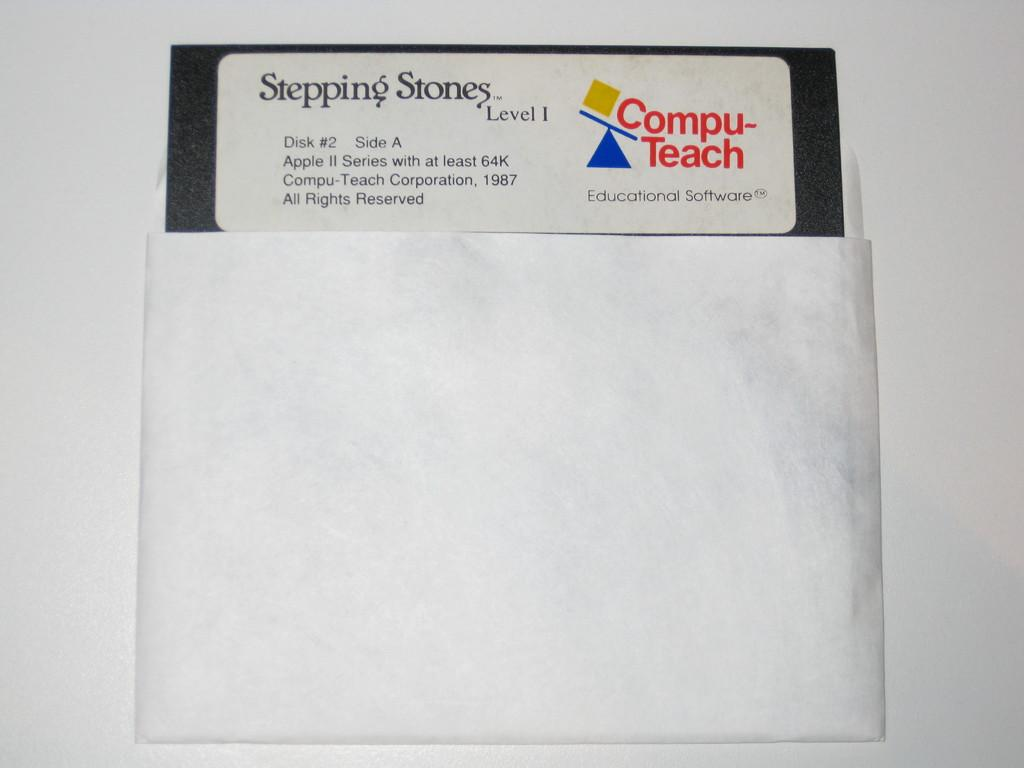<image>
Provide a brief description of the given image. A disk case for an education software called Stepping Stones 